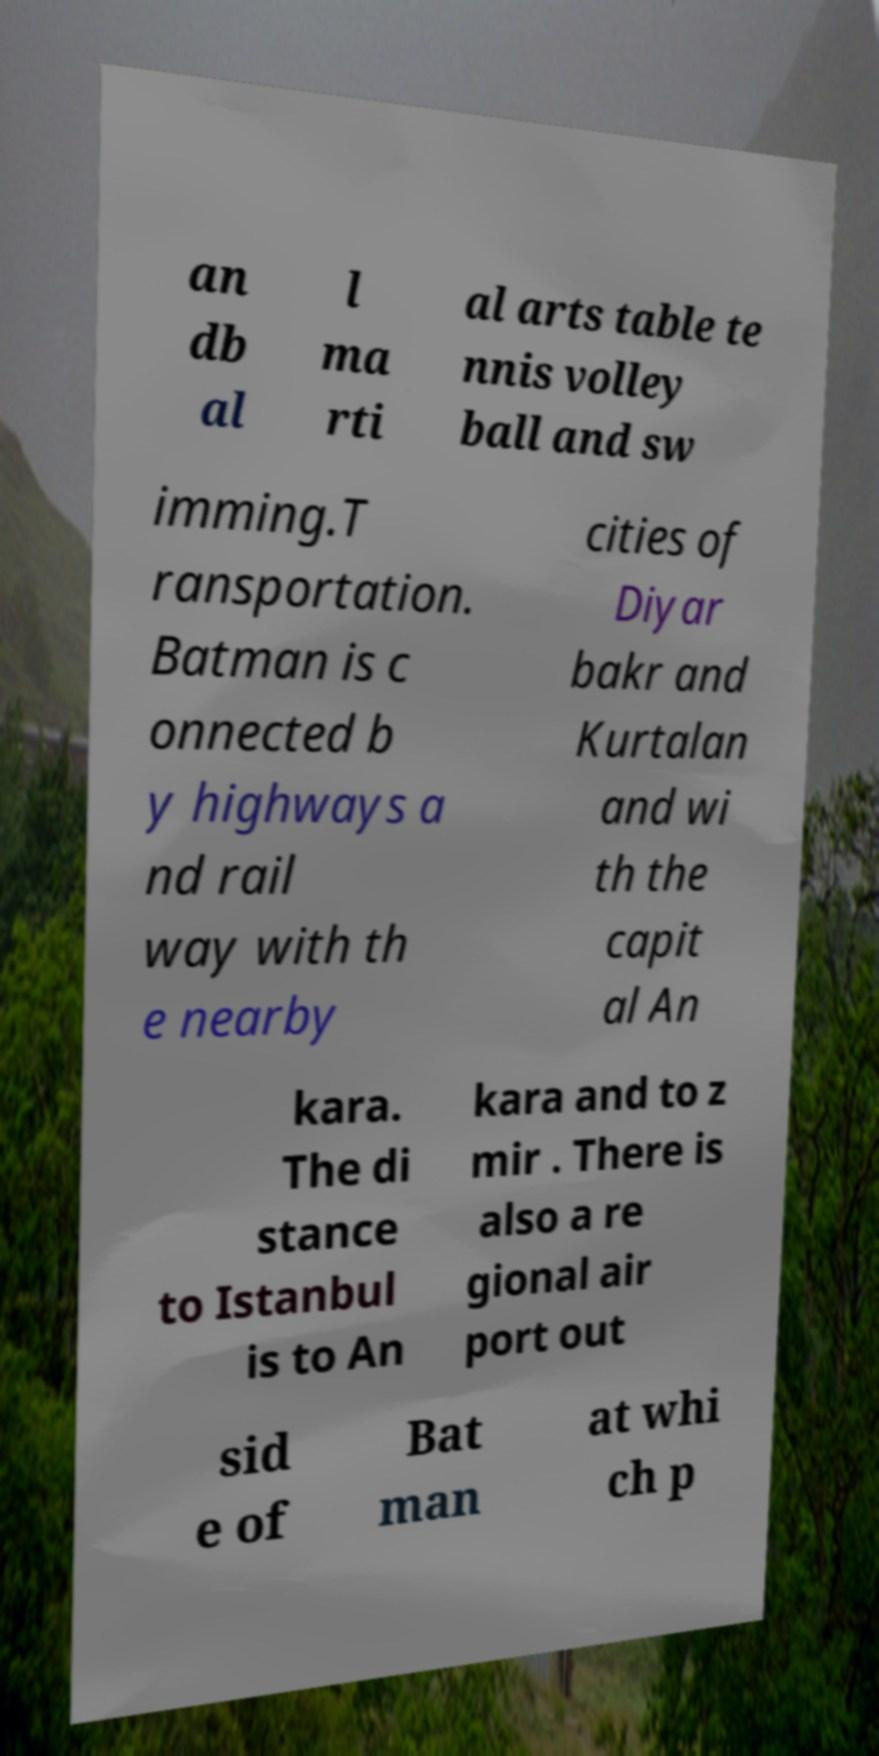Could you assist in decoding the text presented in this image and type it out clearly? an db al l ma rti al arts table te nnis volley ball and sw imming.T ransportation. Batman is c onnected b y highways a nd rail way with th e nearby cities of Diyar bakr and Kurtalan and wi th the capit al An kara. The di stance to Istanbul is to An kara and to z mir . There is also a re gional air port out sid e of Bat man at whi ch p 